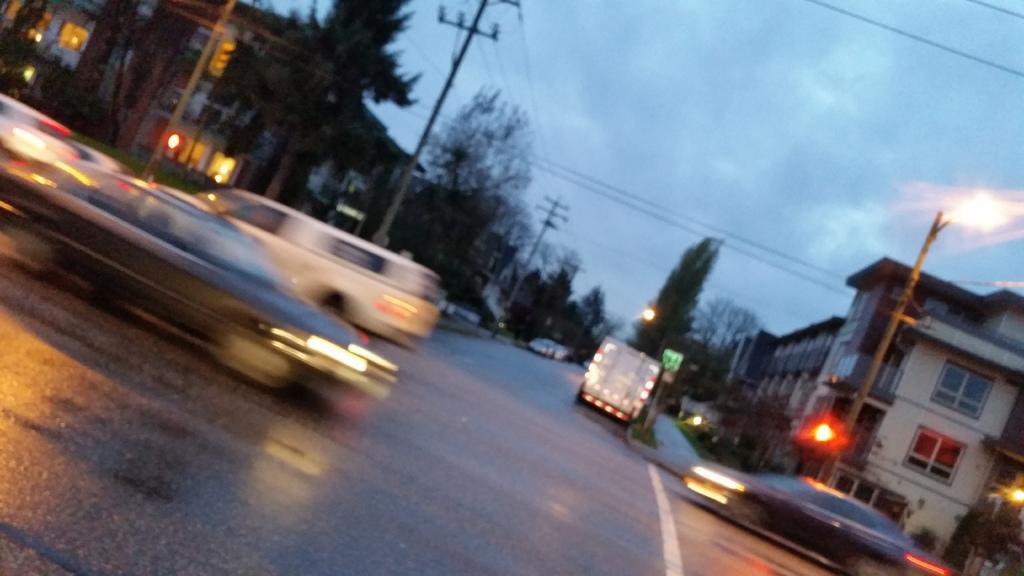How would you summarize this image in a sentence or two? In the background we can see sky. On either side of the road we can see buildings and trees. We can see current poles with wires. Here we can see vehicles on the road. We can see lights. 